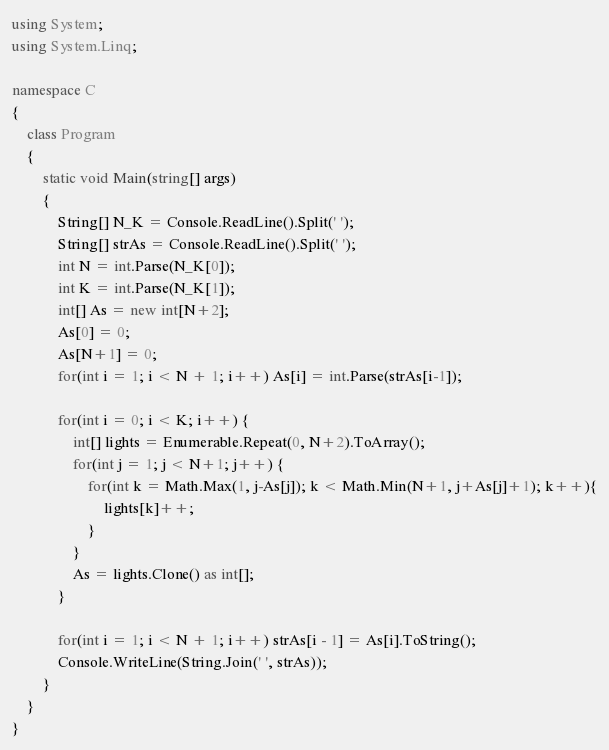<code> <loc_0><loc_0><loc_500><loc_500><_C#_>using System;
using System.Linq;

namespace C
{
    class Program
    {
        static void Main(string[] args)
        {
            String[] N_K = Console.ReadLine().Split(' ');
            String[] strAs = Console.ReadLine().Split(' ');
            int N = int.Parse(N_K[0]);
            int K = int.Parse(N_K[1]);
            int[] As = new int[N+2];
            As[0] = 0;
            As[N+1] = 0;
            for(int i = 1; i < N + 1; i++) As[i] = int.Parse(strAs[i-1]);

            for(int i = 0; i < K; i++) {
                int[] lights = Enumerable.Repeat(0, N+2).ToArray();
                for(int j = 1; j < N+1; j++) {
                    for(int k = Math.Max(1, j-As[j]); k < Math.Min(N+1, j+As[j]+1); k++){
                        lights[k]++;
                    }
                }
                As = lights.Clone() as int[];
            }

            for(int i = 1; i < N + 1; i++) strAs[i - 1] = As[i].ToString();
            Console.WriteLine(String.Join(' ', strAs));
        }
    }
}
</code> 